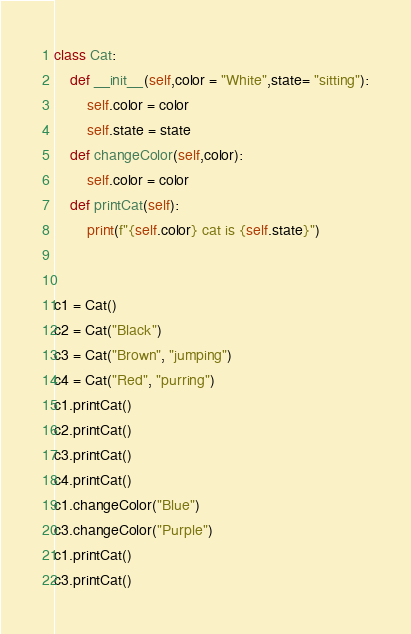<code> <loc_0><loc_0><loc_500><loc_500><_Python_>class Cat:
    def __init__(self,color = "White",state= "sitting"):
        self.color = color
        self.state = state
    def changeColor(self,color):
        self.color = color
    def printCat(self):
        print(f"{self.color} cat is {self.state}")


c1 = Cat()
c2 = Cat("Black")
c3 = Cat("Brown", "jumping")
c4 = Cat("Red", "purring")
c1.printCat()
c2.printCat()
c3.printCat()
c4.printCat()
c1.changeColor("Blue")
c3.changeColor("Purple")
c1.printCat()
c3.printCat()</code> 